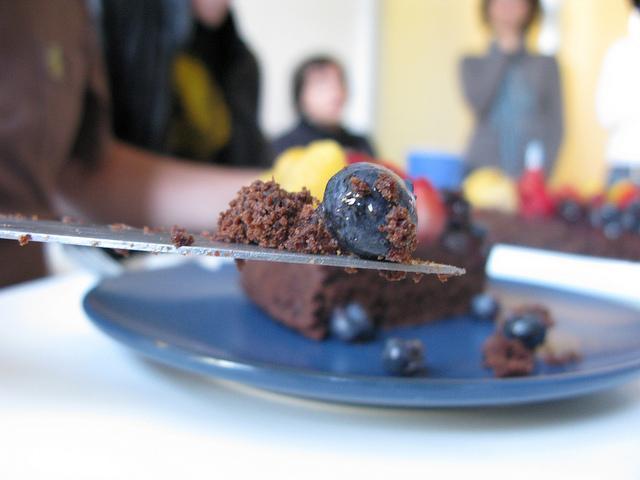How many blueberries are on the plate?
Give a very brief answer. 4. How many people are in the background?
Give a very brief answer. 4. How many people can be seen?
Give a very brief answer. 5. How many cakes are there?
Give a very brief answer. 2. 